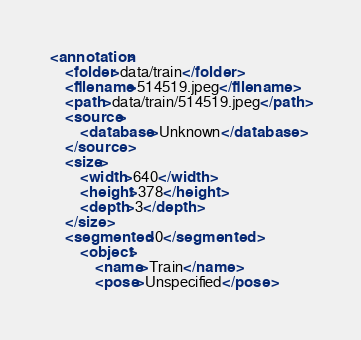Convert code to text. <code><loc_0><loc_0><loc_500><loc_500><_XML_>
<annotation>
    <folder>data/train</folder>
    <filename>514519.jpeg</filename>
    <path>data/train/514519.jpeg</path>
    <source>
        <database>Unknown</database>
    </source>
    <size>
        <width>640</width>
        <height>378</height>
        <depth>3</depth>
    </size>
    <segmented>0</segmented>
        <object>
            <name>Train</name>
            <pose>Unspecified</pose></code> 